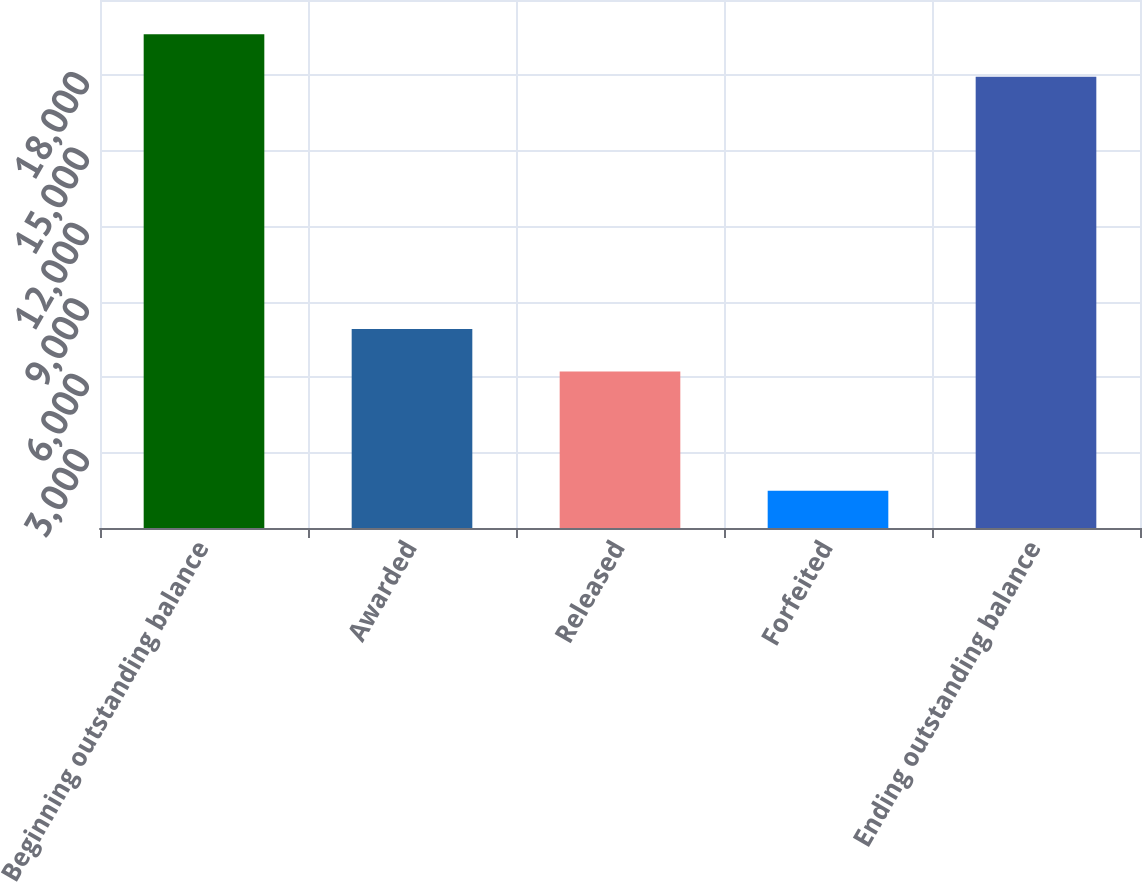Convert chart. <chart><loc_0><loc_0><loc_500><loc_500><bar_chart><fcel>Beginning outstanding balance<fcel>Awarded<fcel>Released<fcel>Forfeited<fcel>Ending outstanding balance<nl><fcel>19641.6<fcel>7917.6<fcel>6224<fcel>1479<fcel>17948<nl></chart> 